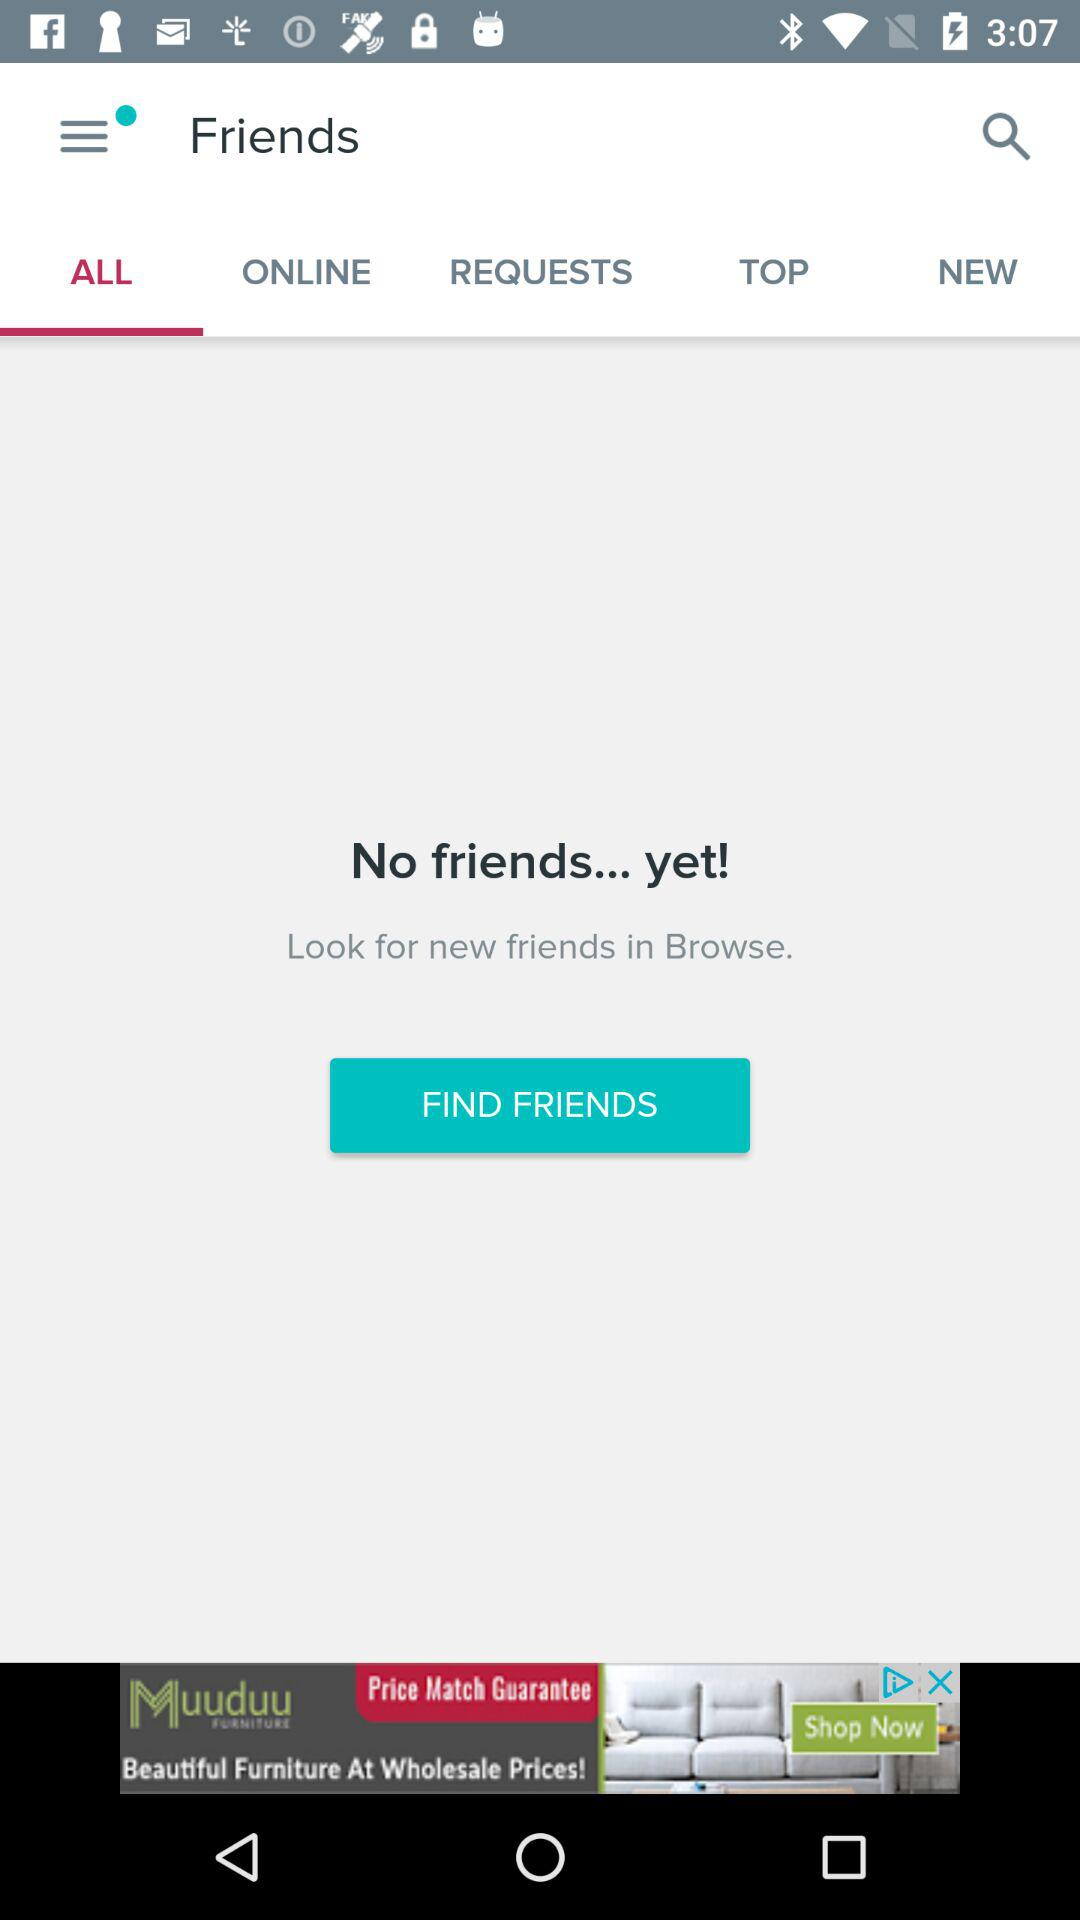Which tab is selected? The selected tab is "ALL". 